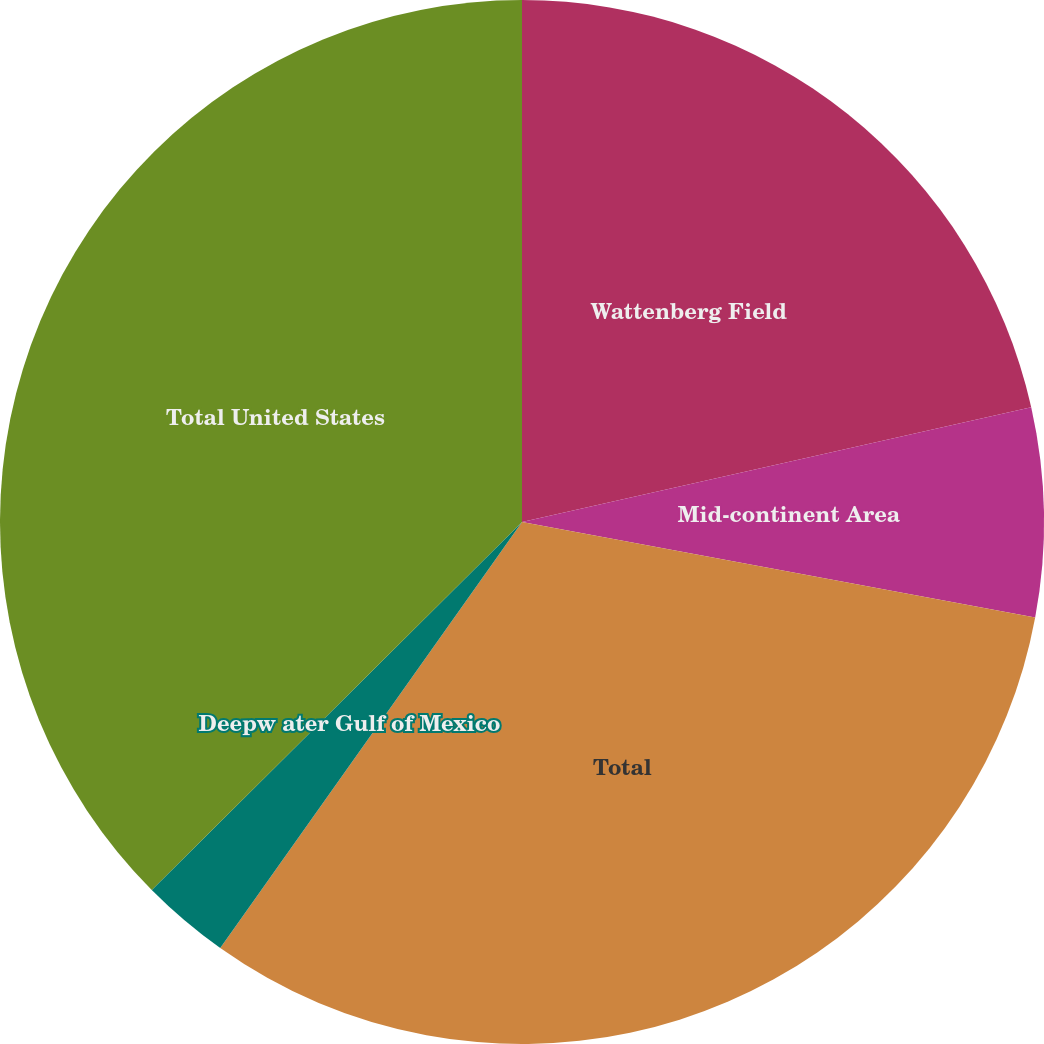Convert chart to OTSL. <chart><loc_0><loc_0><loc_500><loc_500><pie_chart><fcel>Wattenberg Field<fcel>Mid-continent Area<fcel>Total<fcel>Deepw ater Gulf of Mexico<fcel>Total United States<nl><fcel>21.47%<fcel>6.46%<fcel>31.88%<fcel>2.74%<fcel>37.45%<nl></chart> 